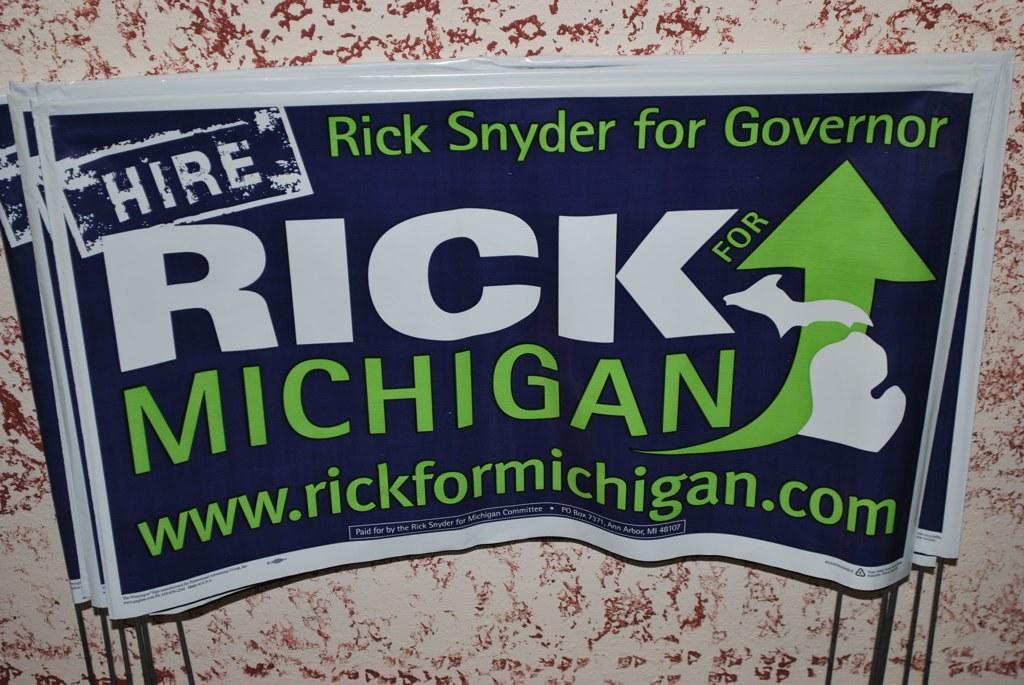What state is mentioned here?
Provide a short and direct response. Michigan. 